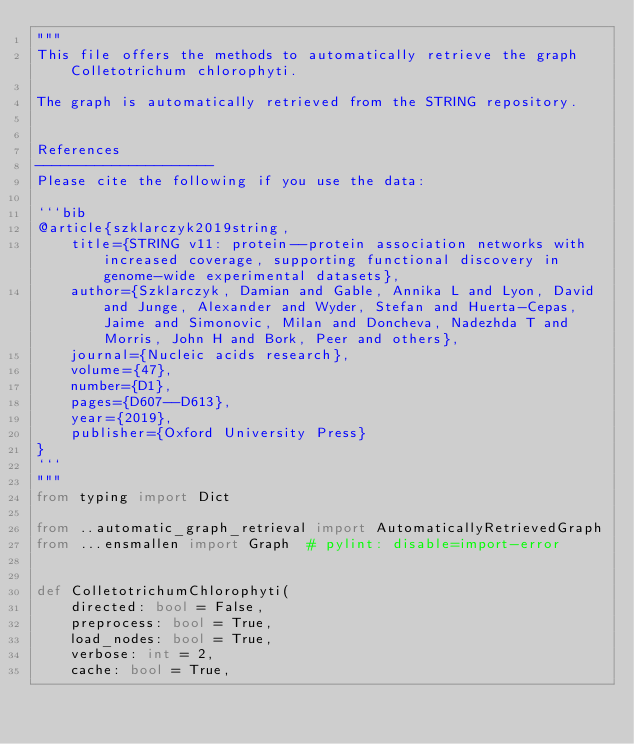Convert code to text. <code><loc_0><loc_0><loc_500><loc_500><_Python_>"""
This file offers the methods to automatically retrieve the graph Colletotrichum chlorophyti.

The graph is automatically retrieved from the STRING repository. 


References
---------------------
Please cite the following if you use the data:

```bib
@article{szklarczyk2019string,
    title={STRING v11: protein--protein association networks with increased coverage, supporting functional discovery in genome-wide experimental datasets},
    author={Szklarczyk, Damian and Gable, Annika L and Lyon, David and Junge, Alexander and Wyder, Stefan and Huerta-Cepas, Jaime and Simonovic, Milan and Doncheva, Nadezhda T and Morris, John H and Bork, Peer and others},
    journal={Nucleic acids research},
    volume={47},
    number={D1},
    pages={D607--D613},
    year={2019},
    publisher={Oxford University Press}
}
```
"""
from typing import Dict

from ..automatic_graph_retrieval import AutomaticallyRetrievedGraph
from ...ensmallen import Graph  # pylint: disable=import-error


def ColletotrichumChlorophyti(
    directed: bool = False,
    preprocess: bool = True,
    load_nodes: bool = True,
    verbose: int = 2,
    cache: bool = True,</code> 